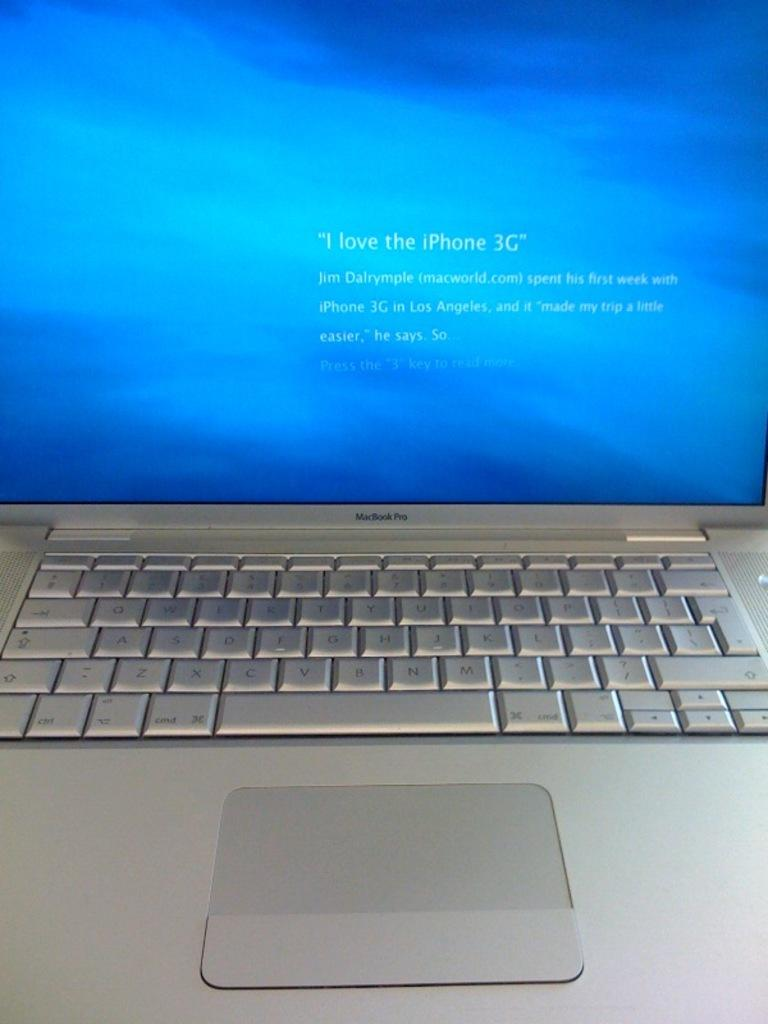<image>
Write a terse but informative summary of the picture. A MacBook Pro laptop with a message on the screen that says "I love the iPhone 3G" 